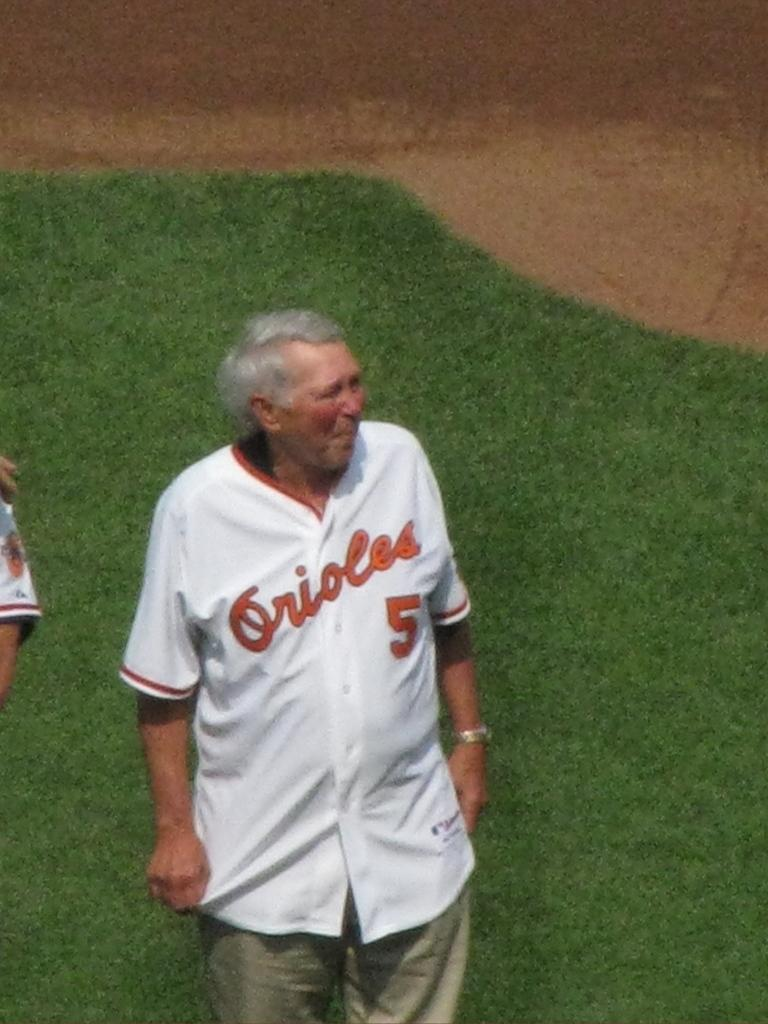Provide a one-sentence caption for the provided image. An old man standing on a ball field wearing an Orioles jersey. 